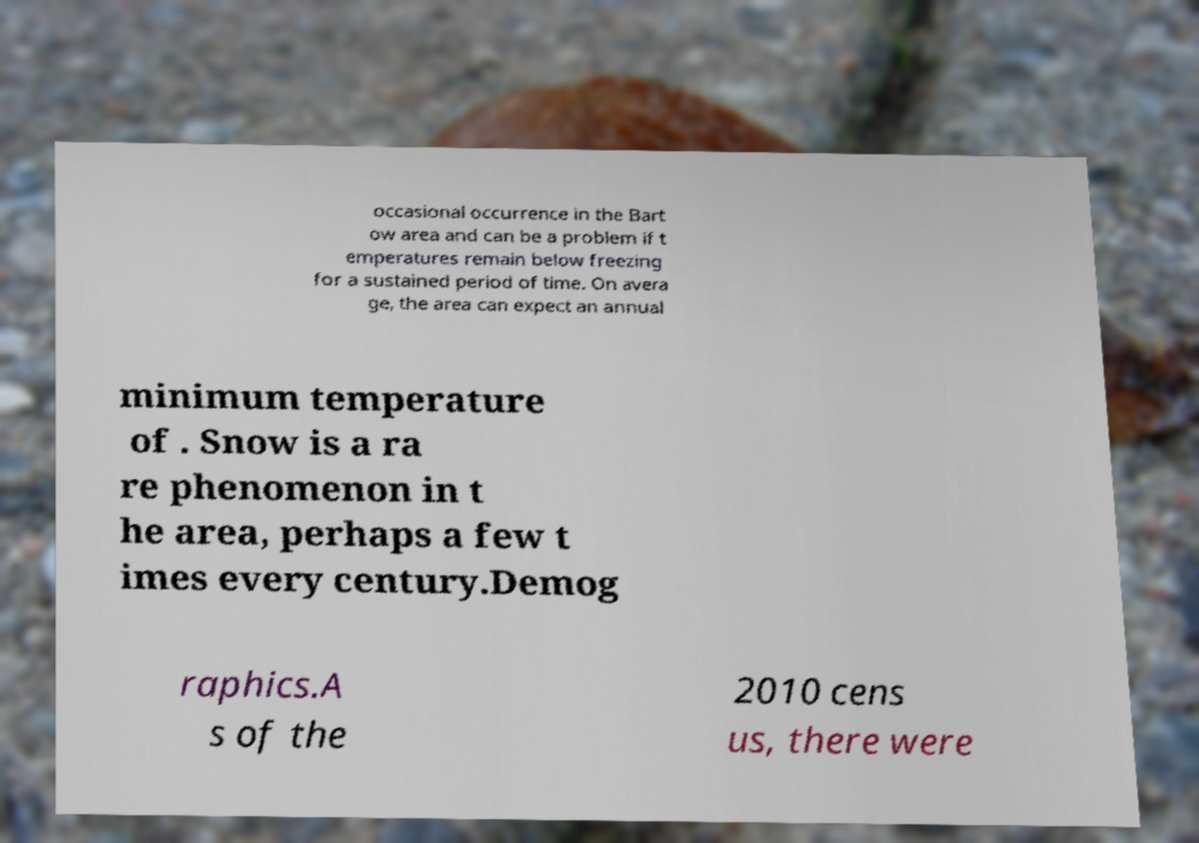Could you extract and type out the text from this image? occasional occurrence in the Bart ow area and can be a problem if t emperatures remain below freezing for a sustained period of time. On avera ge, the area can expect an annual minimum temperature of . Snow is a ra re phenomenon in t he area, perhaps a few t imes every century.Demog raphics.A s of the 2010 cens us, there were 